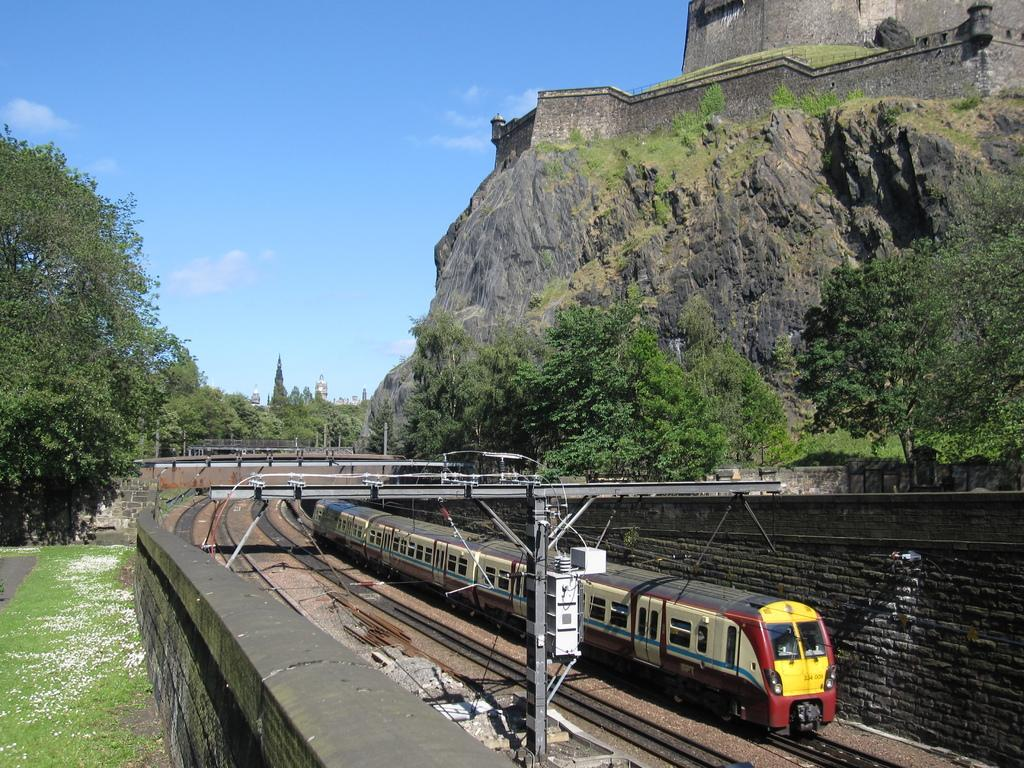What is the main subject of the image? There is a train in the image. Where is the train located? The train is on a railway track. What can be seen on both sides of the image? There are trees on the left and right sides of the image. What other natural element is visible in the image? There is a rock visible in the image. What is visible in the background of the image? There are clouds in the sky in the background of the image. Can you tell me how many beams are supporting the train in the image? There are no beams visible in the image; the train is on a railway track. Is the train's brother also present in the image? There is no mention of a brother or any other person in the image; it only features a train on a railway track. 